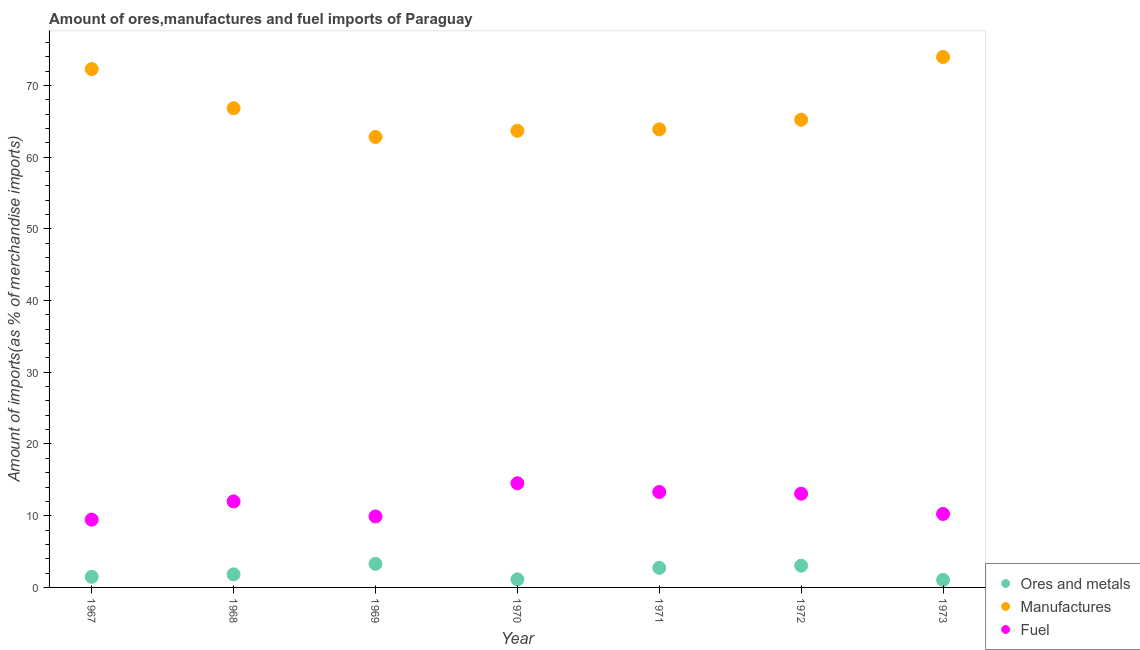How many different coloured dotlines are there?
Provide a succinct answer. 3. Is the number of dotlines equal to the number of legend labels?
Make the answer very short. Yes. What is the percentage of fuel imports in 1972?
Your answer should be very brief. 13.07. Across all years, what is the maximum percentage of ores and metals imports?
Provide a short and direct response. 3.28. Across all years, what is the minimum percentage of manufactures imports?
Your answer should be very brief. 62.81. In which year was the percentage of manufactures imports maximum?
Give a very brief answer. 1973. What is the total percentage of fuel imports in the graph?
Your answer should be compact. 82.49. What is the difference between the percentage of fuel imports in 1967 and that in 1969?
Make the answer very short. -0.44. What is the difference between the percentage of ores and metals imports in 1973 and the percentage of fuel imports in 1971?
Offer a very short reply. -12.26. What is the average percentage of ores and metals imports per year?
Your answer should be very brief. 2.07. In the year 1971, what is the difference between the percentage of ores and metals imports and percentage of fuel imports?
Offer a terse response. -10.58. In how many years, is the percentage of fuel imports greater than 54 %?
Your response must be concise. 0. What is the ratio of the percentage of manufactures imports in 1967 to that in 1972?
Provide a succinct answer. 1.11. Is the percentage of fuel imports in 1969 less than that in 1971?
Your answer should be very brief. Yes. Is the difference between the percentage of manufactures imports in 1968 and 1971 greater than the difference between the percentage of ores and metals imports in 1968 and 1971?
Keep it short and to the point. Yes. What is the difference between the highest and the second highest percentage of manufactures imports?
Provide a short and direct response. 1.69. What is the difference between the highest and the lowest percentage of manufactures imports?
Offer a very short reply. 11.15. Is it the case that in every year, the sum of the percentage of ores and metals imports and percentage of manufactures imports is greater than the percentage of fuel imports?
Give a very brief answer. Yes. How many dotlines are there?
Give a very brief answer. 3. How many years are there in the graph?
Make the answer very short. 7. What is the difference between two consecutive major ticks on the Y-axis?
Offer a terse response. 10. Are the values on the major ticks of Y-axis written in scientific E-notation?
Your answer should be compact. No. Does the graph contain any zero values?
Ensure brevity in your answer.  No. How many legend labels are there?
Make the answer very short. 3. What is the title of the graph?
Your answer should be very brief. Amount of ores,manufactures and fuel imports of Paraguay. Does "Female employers" appear as one of the legend labels in the graph?
Provide a succinct answer. No. What is the label or title of the Y-axis?
Ensure brevity in your answer.  Amount of imports(as % of merchandise imports). What is the Amount of imports(as % of merchandise imports) of Ores and metals in 1967?
Provide a short and direct response. 1.48. What is the Amount of imports(as % of merchandise imports) in Manufactures in 1967?
Offer a terse response. 72.27. What is the Amount of imports(as % of merchandise imports) of Fuel in 1967?
Offer a very short reply. 9.46. What is the Amount of imports(as % of merchandise imports) of Ores and metals in 1968?
Make the answer very short. 1.82. What is the Amount of imports(as % of merchandise imports) of Manufactures in 1968?
Your answer should be compact. 66.82. What is the Amount of imports(as % of merchandise imports) in Fuel in 1968?
Offer a terse response. 11.99. What is the Amount of imports(as % of merchandise imports) in Ores and metals in 1969?
Your answer should be compact. 3.28. What is the Amount of imports(as % of merchandise imports) in Manufactures in 1969?
Offer a terse response. 62.81. What is the Amount of imports(as % of merchandise imports) in Fuel in 1969?
Provide a succinct answer. 9.9. What is the Amount of imports(as % of merchandise imports) in Ores and metals in 1970?
Your answer should be very brief. 1.12. What is the Amount of imports(as % of merchandise imports) in Manufactures in 1970?
Make the answer very short. 63.67. What is the Amount of imports(as % of merchandise imports) of Fuel in 1970?
Make the answer very short. 14.52. What is the Amount of imports(as % of merchandise imports) of Ores and metals in 1971?
Ensure brevity in your answer.  2.73. What is the Amount of imports(as % of merchandise imports) in Manufactures in 1971?
Your answer should be compact. 63.87. What is the Amount of imports(as % of merchandise imports) of Fuel in 1971?
Offer a very short reply. 13.31. What is the Amount of imports(as % of merchandise imports) of Ores and metals in 1972?
Your answer should be very brief. 3.03. What is the Amount of imports(as % of merchandise imports) of Manufactures in 1972?
Make the answer very short. 65.21. What is the Amount of imports(as % of merchandise imports) of Fuel in 1972?
Offer a terse response. 13.07. What is the Amount of imports(as % of merchandise imports) of Ores and metals in 1973?
Make the answer very short. 1.05. What is the Amount of imports(as % of merchandise imports) in Manufactures in 1973?
Give a very brief answer. 73.96. What is the Amount of imports(as % of merchandise imports) in Fuel in 1973?
Make the answer very short. 10.24. Across all years, what is the maximum Amount of imports(as % of merchandise imports) in Ores and metals?
Give a very brief answer. 3.28. Across all years, what is the maximum Amount of imports(as % of merchandise imports) of Manufactures?
Offer a very short reply. 73.96. Across all years, what is the maximum Amount of imports(as % of merchandise imports) in Fuel?
Provide a succinct answer. 14.52. Across all years, what is the minimum Amount of imports(as % of merchandise imports) in Ores and metals?
Provide a short and direct response. 1.05. Across all years, what is the minimum Amount of imports(as % of merchandise imports) in Manufactures?
Your answer should be compact. 62.81. Across all years, what is the minimum Amount of imports(as % of merchandise imports) in Fuel?
Your answer should be very brief. 9.46. What is the total Amount of imports(as % of merchandise imports) of Ores and metals in the graph?
Keep it short and to the point. 14.52. What is the total Amount of imports(as % of merchandise imports) in Manufactures in the graph?
Provide a short and direct response. 468.61. What is the total Amount of imports(as % of merchandise imports) of Fuel in the graph?
Your answer should be very brief. 82.49. What is the difference between the Amount of imports(as % of merchandise imports) in Ores and metals in 1967 and that in 1968?
Offer a very short reply. -0.35. What is the difference between the Amount of imports(as % of merchandise imports) of Manufactures in 1967 and that in 1968?
Keep it short and to the point. 5.45. What is the difference between the Amount of imports(as % of merchandise imports) of Fuel in 1967 and that in 1968?
Offer a very short reply. -2.53. What is the difference between the Amount of imports(as % of merchandise imports) of Ores and metals in 1967 and that in 1969?
Your response must be concise. -1.81. What is the difference between the Amount of imports(as % of merchandise imports) of Manufactures in 1967 and that in 1969?
Your response must be concise. 9.46. What is the difference between the Amount of imports(as % of merchandise imports) in Fuel in 1967 and that in 1969?
Give a very brief answer. -0.44. What is the difference between the Amount of imports(as % of merchandise imports) of Ores and metals in 1967 and that in 1970?
Give a very brief answer. 0.35. What is the difference between the Amount of imports(as % of merchandise imports) of Manufactures in 1967 and that in 1970?
Provide a succinct answer. 8.6. What is the difference between the Amount of imports(as % of merchandise imports) of Fuel in 1967 and that in 1970?
Provide a succinct answer. -5.07. What is the difference between the Amount of imports(as % of merchandise imports) of Ores and metals in 1967 and that in 1971?
Make the answer very short. -1.25. What is the difference between the Amount of imports(as % of merchandise imports) in Manufactures in 1967 and that in 1971?
Make the answer very short. 8.4. What is the difference between the Amount of imports(as % of merchandise imports) in Fuel in 1967 and that in 1971?
Provide a short and direct response. -3.85. What is the difference between the Amount of imports(as % of merchandise imports) of Ores and metals in 1967 and that in 1972?
Your answer should be compact. -1.55. What is the difference between the Amount of imports(as % of merchandise imports) in Manufactures in 1967 and that in 1972?
Your answer should be compact. 7.06. What is the difference between the Amount of imports(as % of merchandise imports) of Fuel in 1967 and that in 1972?
Your response must be concise. -3.61. What is the difference between the Amount of imports(as % of merchandise imports) in Ores and metals in 1967 and that in 1973?
Ensure brevity in your answer.  0.43. What is the difference between the Amount of imports(as % of merchandise imports) of Manufactures in 1967 and that in 1973?
Provide a short and direct response. -1.69. What is the difference between the Amount of imports(as % of merchandise imports) in Fuel in 1967 and that in 1973?
Give a very brief answer. -0.79. What is the difference between the Amount of imports(as % of merchandise imports) in Ores and metals in 1968 and that in 1969?
Provide a succinct answer. -1.46. What is the difference between the Amount of imports(as % of merchandise imports) in Manufactures in 1968 and that in 1969?
Give a very brief answer. 4.01. What is the difference between the Amount of imports(as % of merchandise imports) in Fuel in 1968 and that in 1969?
Offer a very short reply. 2.09. What is the difference between the Amount of imports(as % of merchandise imports) of Ores and metals in 1968 and that in 1970?
Your response must be concise. 0.7. What is the difference between the Amount of imports(as % of merchandise imports) in Manufactures in 1968 and that in 1970?
Ensure brevity in your answer.  3.15. What is the difference between the Amount of imports(as % of merchandise imports) in Fuel in 1968 and that in 1970?
Your response must be concise. -2.53. What is the difference between the Amount of imports(as % of merchandise imports) in Ores and metals in 1968 and that in 1971?
Give a very brief answer. -0.9. What is the difference between the Amount of imports(as % of merchandise imports) in Manufactures in 1968 and that in 1971?
Your answer should be very brief. 2.95. What is the difference between the Amount of imports(as % of merchandise imports) in Fuel in 1968 and that in 1971?
Keep it short and to the point. -1.32. What is the difference between the Amount of imports(as % of merchandise imports) of Ores and metals in 1968 and that in 1972?
Offer a very short reply. -1.2. What is the difference between the Amount of imports(as % of merchandise imports) in Manufactures in 1968 and that in 1972?
Your response must be concise. 1.6. What is the difference between the Amount of imports(as % of merchandise imports) in Fuel in 1968 and that in 1972?
Make the answer very short. -1.08. What is the difference between the Amount of imports(as % of merchandise imports) in Ores and metals in 1968 and that in 1973?
Give a very brief answer. 0.77. What is the difference between the Amount of imports(as % of merchandise imports) in Manufactures in 1968 and that in 1973?
Your answer should be compact. -7.15. What is the difference between the Amount of imports(as % of merchandise imports) of Fuel in 1968 and that in 1973?
Your answer should be very brief. 1.75. What is the difference between the Amount of imports(as % of merchandise imports) in Ores and metals in 1969 and that in 1970?
Ensure brevity in your answer.  2.16. What is the difference between the Amount of imports(as % of merchandise imports) of Manufactures in 1969 and that in 1970?
Make the answer very short. -0.86. What is the difference between the Amount of imports(as % of merchandise imports) of Fuel in 1969 and that in 1970?
Offer a terse response. -4.62. What is the difference between the Amount of imports(as % of merchandise imports) in Ores and metals in 1969 and that in 1971?
Provide a succinct answer. 0.55. What is the difference between the Amount of imports(as % of merchandise imports) of Manufactures in 1969 and that in 1971?
Provide a succinct answer. -1.06. What is the difference between the Amount of imports(as % of merchandise imports) in Fuel in 1969 and that in 1971?
Give a very brief answer. -3.41. What is the difference between the Amount of imports(as % of merchandise imports) in Ores and metals in 1969 and that in 1972?
Provide a short and direct response. 0.25. What is the difference between the Amount of imports(as % of merchandise imports) in Manufactures in 1969 and that in 1972?
Make the answer very short. -2.4. What is the difference between the Amount of imports(as % of merchandise imports) of Fuel in 1969 and that in 1972?
Your response must be concise. -3.17. What is the difference between the Amount of imports(as % of merchandise imports) of Ores and metals in 1969 and that in 1973?
Give a very brief answer. 2.23. What is the difference between the Amount of imports(as % of merchandise imports) in Manufactures in 1969 and that in 1973?
Your answer should be very brief. -11.15. What is the difference between the Amount of imports(as % of merchandise imports) in Fuel in 1969 and that in 1973?
Your response must be concise. -0.34. What is the difference between the Amount of imports(as % of merchandise imports) of Ores and metals in 1970 and that in 1971?
Your answer should be compact. -1.61. What is the difference between the Amount of imports(as % of merchandise imports) in Manufactures in 1970 and that in 1971?
Give a very brief answer. -0.2. What is the difference between the Amount of imports(as % of merchandise imports) of Fuel in 1970 and that in 1971?
Provide a succinct answer. 1.22. What is the difference between the Amount of imports(as % of merchandise imports) in Ores and metals in 1970 and that in 1972?
Offer a very short reply. -1.91. What is the difference between the Amount of imports(as % of merchandise imports) of Manufactures in 1970 and that in 1972?
Make the answer very short. -1.55. What is the difference between the Amount of imports(as % of merchandise imports) in Fuel in 1970 and that in 1972?
Offer a very short reply. 1.46. What is the difference between the Amount of imports(as % of merchandise imports) of Ores and metals in 1970 and that in 1973?
Your response must be concise. 0.07. What is the difference between the Amount of imports(as % of merchandise imports) in Manufactures in 1970 and that in 1973?
Your response must be concise. -10.3. What is the difference between the Amount of imports(as % of merchandise imports) in Fuel in 1970 and that in 1973?
Provide a short and direct response. 4.28. What is the difference between the Amount of imports(as % of merchandise imports) in Ores and metals in 1971 and that in 1972?
Your response must be concise. -0.3. What is the difference between the Amount of imports(as % of merchandise imports) in Manufactures in 1971 and that in 1972?
Your answer should be compact. -1.35. What is the difference between the Amount of imports(as % of merchandise imports) of Fuel in 1971 and that in 1972?
Offer a very short reply. 0.24. What is the difference between the Amount of imports(as % of merchandise imports) in Ores and metals in 1971 and that in 1973?
Give a very brief answer. 1.68. What is the difference between the Amount of imports(as % of merchandise imports) in Manufactures in 1971 and that in 1973?
Keep it short and to the point. -10.1. What is the difference between the Amount of imports(as % of merchandise imports) in Fuel in 1971 and that in 1973?
Offer a terse response. 3.07. What is the difference between the Amount of imports(as % of merchandise imports) of Ores and metals in 1972 and that in 1973?
Your answer should be compact. 1.98. What is the difference between the Amount of imports(as % of merchandise imports) in Manufactures in 1972 and that in 1973?
Ensure brevity in your answer.  -8.75. What is the difference between the Amount of imports(as % of merchandise imports) of Fuel in 1972 and that in 1973?
Your answer should be very brief. 2.83. What is the difference between the Amount of imports(as % of merchandise imports) of Ores and metals in 1967 and the Amount of imports(as % of merchandise imports) of Manufactures in 1968?
Provide a short and direct response. -65.34. What is the difference between the Amount of imports(as % of merchandise imports) in Ores and metals in 1967 and the Amount of imports(as % of merchandise imports) in Fuel in 1968?
Keep it short and to the point. -10.51. What is the difference between the Amount of imports(as % of merchandise imports) in Manufactures in 1967 and the Amount of imports(as % of merchandise imports) in Fuel in 1968?
Give a very brief answer. 60.28. What is the difference between the Amount of imports(as % of merchandise imports) of Ores and metals in 1967 and the Amount of imports(as % of merchandise imports) of Manufactures in 1969?
Make the answer very short. -61.33. What is the difference between the Amount of imports(as % of merchandise imports) of Ores and metals in 1967 and the Amount of imports(as % of merchandise imports) of Fuel in 1969?
Offer a very short reply. -8.42. What is the difference between the Amount of imports(as % of merchandise imports) of Manufactures in 1967 and the Amount of imports(as % of merchandise imports) of Fuel in 1969?
Provide a succinct answer. 62.37. What is the difference between the Amount of imports(as % of merchandise imports) in Ores and metals in 1967 and the Amount of imports(as % of merchandise imports) in Manufactures in 1970?
Offer a terse response. -62.19. What is the difference between the Amount of imports(as % of merchandise imports) of Ores and metals in 1967 and the Amount of imports(as % of merchandise imports) of Fuel in 1970?
Offer a terse response. -13.05. What is the difference between the Amount of imports(as % of merchandise imports) of Manufactures in 1967 and the Amount of imports(as % of merchandise imports) of Fuel in 1970?
Your response must be concise. 57.75. What is the difference between the Amount of imports(as % of merchandise imports) of Ores and metals in 1967 and the Amount of imports(as % of merchandise imports) of Manufactures in 1971?
Offer a very short reply. -62.39. What is the difference between the Amount of imports(as % of merchandise imports) of Ores and metals in 1967 and the Amount of imports(as % of merchandise imports) of Fuel in 1971?
Keep it short and to the point. -11.83. What is the difference between the Amount of imports(as % of merchandise imports) of Manufactures in 1967 and the Amount of imports(as % of merchandise imports) of Fuel in 1971?
Provide a short and direct response. 58.96. What is the difference between the Amount of imports(as % of merchandise imports) in Ores and metals in 1967 and the Amount of imports(as % of merchandise imports) in Manufactures in 1972?
Give a very brief answer. -63.74. What is the difference between the Amount of imports(as % of merchandise imports) in Ores and metals in 1967 and the Amount of imports(as % of merchandise imports) in Fuel in 1972?
Provide a short and direct response. -11.59. What is the difference between the Amount of imports(as % of merchandise imports) in Manufactures in 1967 and the Amount of imports(as % of merchandise imports) in Fuel in 1972?
Offer a terse response. 59.2. What is the difference between the Amount of imports(as % of merchandise imports) in Ores and metals in 1967 and the Amount of imports(as % of merchandise imports) in Manufactures in 1973?
Provide a short and direct response. -72.48. What is the difference between the Amount of imports(as % of merchandise imports) of Ores and metals in 1967 and the Amount of imports(as % of merchandise imports) of Fuel in 1973?
Keep it short and to the point. -8.76. What is the difference between the Amount of imports(as % of merchandise imports) of Manufactures in 1967 and the Amount of imports(as % of merchandise imports) of Fuel in 1973?
Make the answer very short. 62.03. What is the difference between the Amount of imports(as % of merchandise imports) of Ores and metals in 1968 and the Amount of imports(as % of merchandise imports) of Manufactures in 1969?
Give a very brief answer. -60.98. What is the difference between the Amount of imports(as % of merchandise imports) of Ores and metals in 1968 and the Amount of imports(as % of merchandise imports) of Fuel in 1969?
Your answer should be compact. -8.07. What is the difference between the Amount of imports(as % of merchandise imports) in Manufactures in 1968 and the Amount of imports(as % of merchandise imports) in Fuel in 1969?
Provide a succinct answer. 56.92. What is the difference between the Amount of imports(as % of merchandise imports) of Ores and metals in 1968 and the Amount of imports(as % of merchandise imports) of Manufactures in 1970?
Keep it short and to the point. -61.84. What is the difference between the Amount of imports(as % of merchandise imports) in Ores and metals in 1968 and the Amount of imports(as % of merchandise imports) in Fuel in 1970?
Your response must be concise. -12.7. What is the difference between the Amount of imports(as % of merchandise imports) in Manufactures in 1968 and the Amount of imports(as % of merchandise imports) in Fuel in 1970?
Provide a succinct answer. 52.29. What is the difference between the Amount of imports(as % of merchandise imports) in Ores and metals in 1968 and the Amount of imports(as % of merchandise imports) in Manufactures in 1971?
Provide a short and direct response. -62.04. What is the difference between the Amount of imports(as % of merchandise imports) of Ores and metals in 1968 and the Amount of imports(as % of merchandise imports) of Fuel in 1971?
Provide a short and direct response. -11.48. What is the difference between the Amount of imports(as % of merchandise imports) of Manufactures in 1968 and the Amount of imports(as % of merchandise imports) of Fuel in 1971?
Provide a succinct answer. 53.51. What is the difference between the Amount of imports(as % of merchandise imports) of Ores and metals in 1968 and the Amount of imports(as % of merchandise imports) of Manufactures in 1972?
Provide a short and direct response. -63.39. What is the difference between the Amount of imports(as % of merchandise imports) in Ores and metals in 1968 and the Amount of imports(as % of merchandise imports) in Fuel in 1972?
Offer a terse response. -11.24. What is the difference between the Amount of imports(as % of merchandise imports) of Manufactures in 1968 and the Amount of imports(as % of merchandise imports) of Fuel in 1972?
Keep it short and to the point. 53.75. What is the difference between the Amount of imports(as % of merchandise imports) in Ores and metals in 1968 and the Amount of imports(as % of merchandise imports) in Manufactures in 1973?
Make the answer very short. -72.14. What is the difference between the Amount of imports(as % of merchandise imports) of Ores and metals in 1968 and the Amount of imports(as % of merchandise imports) of Fuel in 1973?
Provide a succinct answer. -8.42. What is the difference between the Amount of imports(as % of merchandise imports) in Manufactures in 1968 and the Amount of imports(as % of merchandise imports) in Fuel in 1973?
Make the answer very short. 56.57. What is the difference between the Amount of imports(as % of merchandise imports) in Ores and metals in 1969 and the Amount of imports(as % of merchandise imports) in Manufactures in 1970?
Your response must be concise. -60.38. What is the difference between the Amount of imports(as % of merchandise imports) in Ores and metals in 1969 and the Amount of imports(as % of merchandise imports) in Fuel in 1970?
Give a very brief answer. -11.24. What is the difference between the Amount of imports(as % of merchandise imports) in Manufactures in 1969 and the Amount of imports(as % of merchandise imports) in Fuel in 1970?
Make the answer very short. 48.29. What is the difference between the Amount of imports(as % of merchandise imports) in Ores and metals in 1969 and the Amount of imports(as % of merchandise imports) in Manufactures in 1971?
Offer a terse response. -60.58. What is the difference between the Amount of imports(as % of merchandise imports) in Ores and metals in 1969 and the Amount of imports(as % of merchandise imports) in Fuel in 1971?
Offer a very short reply. -10.02. What is the difference between the Amount of imports(as % of merchandise imports) in Manufactures in 1969 and the Amount of imports(as % of merchandise imports) in Fuel in 1971?
Give a very brief answer. 49.5. What is the difference between the Amount of imports(as % of merchandise imports) of Ores and metals in 1969 and the Amount of imports(as % of merchandise imports) of Manufactures in 1972?
Your response must be concise. -61.93. What is the difference between the Amount of imports(as % of merchandise imports) in Ores and metals in 1969 and the Amount of imports(as % of merchandise imports) in Fuel in 1972?
Keep it short and to the point. -9.78. What is the difference between the Amount of imports(as % of merchandise imports) of Manufactures in 1969 and the Amount of imports(as % of merchandise imports) of Fuel in 1972?
Your answer should be compact. 49.74. What is the difference between the Amount of imports(as % of merchandise imports) of Ores and metals in 1969 and the Amount of imports(as % of merchandise imports) of Manufactures in 1973?
Keep it short and to the point. -70.68. What is the difference between the Amount of imports(as % of merchandise imports) of Ores and metals in 1969 and the Amount of imports(as % of merchandise imports) of Fuel in 1973?
Your answer should be very brief. -6.96. What is the difference between the Amount of imports(as % of merchandise imports) of Manufactures in 1969 and the Amount of imports(as % of merchandise imports) of Fuel in 1973?
Offer a terse response. 52.57. What is the difference between the Amount of imports(as % of merchandise imports) in Ores and metals in 1970 and the Amount of imports(as % of merchandise imports) in Manufactures in 1971?
Offer a terse response. -62.74. What is the difference between the Amount of imports(as % of merchandise imports) in Ores and metals in 1970 and the Amount of imports(as % of merchandise imports) in Fuel in 1971?
Provide a succinct answer. -12.18. What is the difference between the Amount of imports(as % of merchandise imports) in Manufactures in 1970 and the Amount of imports(as % of merchandise imports) in Fuel in 1971?
Provide a short and direct response. 50.36. What is the difference between the Amount of imports(as % of merchandise imports) of Ores and metals in 1970 and the Amount of imports(as % of merchandise imports) of Manufactures in 1972?
Keep it short and to the point. -64.09. What is the difference between the Amount of imports(as % of merchandise imports) in Ores and metals in 1970 and the Amount of imports(as % of merchandise imports) in Fuel in 1972?
Offer a very short reply. -11.94. What is the difference between the Amount of imports(as % of merchandise imports) in Manufactures in 1970 and the Amount of imports(as % of merchandise imports) in Fuel in 1972?
Keep it short and to the point. 50.6. What is the difference between the Amount of imports(as % of merchandise imports) in Ores and metals in 1970 and the Amount of imports(as % of merchandise imports) in Manufactures in 1973?
Offer a very short reply. -72.84. What is the difference between the Amount of imports(as % of merchandise imports) in Ores and metals in 1970 and the Amount of imports(as % of merchandise imports) in Fuel in 1973?
Keep it short and to the point. -9.12. What is the difference between the Amount of imports(as % of merchandise imports) of Manufactures in 1970 and the Amount of imports(as % of merchandise imports) of Fuel in 1973?
Ensure brevity in your answer.  53.43. What is the difference between the Amount of imports(as % of merchandise imports) in Ores and metals in 1971 and the Amount of imports(as % of merchandise imports) in Manufactures in 1972?
Give a very brief answer. -62.48. What is the difference between the Amount of imports(as % of merchandise imports) of Ores and metals in 1971 and the Amount of imports(as % of merchandise imports) of Fuel in 1972?
Provide a succinct answer. -10.34. What is the difference between the Amount of imports(as % of merchandise imports) of Manufactures in 1971 and the Amount of imports(as % of merchandise imports) of Fuel in 1972?
Your response must be concise. 50.8. What is the difference between the Amount of imports(as % of merchandise imports) of Ores and metals in 1971 and the Amount of imports(as % of merchandise imports) of Manufactures in 1973?
Offer a very short reply. -71.23. What is the difference between the Amount of imports(as % of merchandise imports) of Ores and metals in 1971 and the Amount of imports(as % of merchandise imports) of Fuel in 1973?
Provide a short and direct response. -7.51. What is the difference between the Amount of imports(as % of merchandise imports) in Manufactures in 1971 and the Amount of imports(as % of merchandise imports) in Fuel in 1973?
Provide a succinct answer. 53.63. What is the difference between the Amount of imports(as % of merchandise imports) in Ores and metals in 1972 and the Amount of imports(as % of merchandise imports) in Manufactures in 1973?
Your response must be concise. -70.93. What is the difference between the Amount of imports(as % of merchandise imports) in Ores and metals in 1972 and the Amount of imports(as % of merchandise imports) in Fuel in 1973?
Provide a succinct answer. -7.21. What is the difference between the Amount of imports(as % of merchandise imports) of Manufactures in 1972 and the Amount of imports(as % of merchandise imports) of Fuel in 1973?
Provide a succinct answer. 54.97. What is the average Amount of imports(as % of merchandise imports) of Ores and metals per year?
Make the answer very short. 2.07. What is the average Amount of imports(as % of merchandise imports) in Manufactures per year?
Provide a short and direct response. 66.94. What is the average Amount of imports(as % of merchandise imports) of Fuel per year?
Provide a succinct answer. 11.78. In the year 1967, what is the difference between the Amount of imports(as % of merchandise imports) in Ores and metals and Amount of imports(as % of merchandise imports) in Manufactures?
Ensure brevity in your answer.  -70.79. In the year 1967, what is the difference between the Amount of imports(as % of merchandise imports) in Ores and metals and Amount of imports(as % of merchandise imports) in Fuel?
Your answer should be compact. -7.98. In the year 1967, what is the difference between the Amount of imports(as % of merchandise imports) in Manufactures and Amount of imports(as % of merchandise imports) in Fuel?
Your response must be concise. 62.82. In the year 1968, what is the difference between the Amount of imports(as % of merchandise imports) of Ores and metals and Amount of imports(as % of merchandise imports) of Manufactures?
Provide a short and direct response. -64.99. In the year 1968, what is the difference between the Amount of imports(as % of merchandise imports) in Ores and metals and Amount of imports(as % of merchandise imports) in Fuel?
Provide a succinct answer. -10.16. In the year 1968, what is the difference between the Amount of imports(as % of merchandise imports) in Manufactures and Amount of imports(as % of merchandise imports) in Fuel?
Offer a very short reply. 54.83. In the year 1969, what is the difference between the Amount of imports(as % of merchandise imports) in Ores and metals and Amount of imports(as % of merchandise imports) in Manufactures?
Offer a very short reply. -59.53. In the year 1969, what is the difference between the Amount of imports(as % of merchandise imports) of Ores and metals and Amount of imports(as % of merchandise imports) of Fuel?
Your response must be concise. -6.62. In the year 1969, what is the difference between the Amount of imports(as % of merchandise imports) of Manufactures and Amount of imports(as % of merchandise imports) of Fuel?
Your answer should be compact. 52.91. In the year 1970, what is the difference between the Amount of imports(as % of merchandise imports) of Ores and metals and Amount of imports(as % of merchandise imports) of Manufactures?
Your answer should be very brief. -62.54. In the year 1970, what is the difference between the Amount of imports(as % of merchandise imports) in Ores and metals and Amount of imports(as % of merchandise imports) in Fuel?
Ensure brevity in your answer.  -13.4. In the year 1970, what is the difference between the Amount of imports(as % of merchandise imports) of Manufactures and Amount of imports(as % of merchandise imports) of Fuel?
Provide a succinct answer. 49.14. In the year 1971, what is the difference between the Amount of imports(as % of merchandise imports) in Ores and metals and Amount of imports(as % of merchandise imports) in Manufactures?
Your response must be concise. -61.14. In the year 1971, what is the difference between the Amount of imports(as % of merchandise imports) in Ores and metals and Amount of imports(as % of merchandise imports) in Fuel?
Provide a short and direct response. -10.58. In the year 1971, what is the difference between the Amount of imports(as % of merchandise imports) in Manufactures and Amount of imports(as % of merchandise imports) in Fuel?
Give a very brief answer. 50.56. In the year 1972, what is the difference between the Amount of imports(as % of merchandise imports) in Ores and metals and Amount of imports(as % of merchandise imports) in Manufactures?
Your response must be concise. -62.18. In the year 1972, what is the difference between the Amount of imports(as % of merchandise imports) in Ores and metals and Amount of imports(as % of merchandise imports) in Fuel?
Give a very brief answer. -10.04. In the year 1972, what is the difference between the Amount of imports(as % of merchandise imports) in Manufactures and Amount of imports(as % of merchandise imports) in Fuel?
Make the answer very short. 52.15. In the year 1973, what is the difference between the Amount of imports(as % of merchandise imports) of Ores and metals and Amount of imports(as % of merchandise imports) of Manufactures?
Offer a very short reply. -72.91. In the year 1973, what is the difference between the Amount of imports(as % of merchandise imports) of Ores and metals and Amount of imports(as % of merchandise imports) of Fuel?
Your response must be concise. -9.19. In the year 1973, what is the difference between the Amount of imports(as % of merchandise imports) in Manufactures and Amount of imports(as % of merchandise imports) in Fuel?
Offer a very short reply. 63.72. What is the ratio of the Amount of imports(as % of merchandise imports) of Ores and metals in 1967 to that in 1968?
Your response must be concise. 0.81. What is the ratio of the Amount of imports(as % of merchandise imports) of Manufactures in 1967 to that in 1968?
Your answer should be very brief. 1.08. What is the ratio of the Amount of imports(as % of merchandise imports) of Fuel in 1967 to that in 1968?
Your response must be concise. 0.79. What is the ratio of the Amount of imports(as % of merchandise imports) in Ores and metals in 1967 to that in 1969?
Your answer should be compact. 0.45. What is the ratio of the Amount of imports(as % of merchandise imports) in Manufactures in 1967 to that in 1969?
Your answer should be very brief. 1.15. What is the ratio of the Amount of imports(as % of merchandise imports) in Fuel in 1967 to that in 1969?
Ensure brevity in your answer.  0.96. What is the ratio of the Amount of imports(as % of merchandise imports) of Ores and metals in 1967 to that in 1970?
Ensure brevity in your answer.  1.32. What is the ratio of the Amount of imports(as % of merchandise imports) of Manufactures in 1967 to that in 1970?
Your answer should be compact. 1.14. What is the ratio of the Amount of imports(as % of merchandise imports) in Fuel in 1967 to that in 1970?
Make the answer very short. 0.65. What is the ratio of the Amount of imports(as % of merchandise imports) in Ores and metals in 1967 to that in 1971?
Offer a terse response. 0.54. What is the ratio of the Amount of imports(as % of merchandise imports) in Manufactures in 1967 to that in 1971?
Your answer should be very brief. 1.13. What is the ratio of the Amount of imports(as % of merchandise imports) in Fuel in 1967 to that in 1971?
Offer a very short reply. 0.71. What is the ratio of the Amount of imports(as % of merchandise imports) of Ores and metals in 1967 to that in 1972?
Provide a succinct answer. 0.49. What is the ratio of the Amount of imports(as % of merchandise imports) in Manufactures in 1967 to that in 1972?
Offer a terse response. 1.11. What is the ratio of the Amount of imports(as % of merchandise imports) of Fuel in 1967 to that in 1972?
Provide a succinct answer. 0.72. What is the ratio of the Amount of imports(as % of merchandise imports) in Ores and metals in 1967 to that in 1973?
Your response must be concise. 1.41. What is the ratio of the Amount of imports(as % of merchandise imports) of Manufactures in 1967 to that in 1973?
Give a very brief answer. 0.98. What is the ratio of the Amount of imports(as % of merchandise imports) of Fuel in 1967 to that in 1973?
Provide a short and direct response. 0.92. What is the ratio of the Amount of imports(as % of merchandise imports) of Ores and metals in 1968 to that in 1969?
Provide a short and direct response. 0.56. What is the ratio of the Amount of imports(as % of merchandise imports) in Manufactures in 1968 to that in 1969?
Your answer should be compact. 1.06. What is the ratio of the Amount of imports(as % of merchandise imports) in Fuel in 1968 to that in 1969?
Offer a terse response. 1.21. What is the ratio of the Amount of imports(as % of merchandise imports) in Ores and metals in 1968 to that in 1970?
Provide a succinct answer. 1.62. What is the ratio of the Amount of imports(as % of merchandise imports) of Manufactures in 1968 to that in 1970?
Ensure brevity in your answer.  1.05. What is the ratio of the Amount of imports(as % of merchandise imports) of Fuel in 1968 to that in 1970?
Your response must be concise. 0.83. What is the ratio of the Amount of imports(as % of merchandise imports) of Ores and metals in 1968 to that in 1971?
Keep it short and to the point. 0.67. What is the ratio of the Amount of imports(as % of merchandise imports) in Manufactures in 1968 to that in 1971?
Offer a terse response. 1.05. What is the ratio of the Amount of imports(as % of merchandise imports) of Fuel in 1968 to that in 1971?
Provide a succinct answer. 0.9. What is the ratio of the Amount of imports(as % of merchandise imports) of Ores and metals in 1968 to that in 1972?
Your answer should be very brief. 0.6. What is the ratio of the Amount of imports(as % of merchandise imports) of Manufactures in 1968 to that in 1972?
Give a very brief answer. 1.02. What is the ratio of the Amount of imports(as % of merchandise imports) of Fuel in 1968 to that in 1972?
Offer a very short reply. 0.92. What is the ratio of the Amount of imports(as % of merchandise imports) of Ores and metals in 1968 to that in 1973?
Your answer should be compact. 1.74. What is the ratio of the Amount of imports(as % of merchandise imports) in Manufactures in 1968 to that in 1973?
Keep it short and to the point. 0.9. What is the ratio of the Amount of imports(as % of merchandise imports) in Fuel in 1968 to that in 1973?
Your answer should be compact. 1.17. What is the ratio of the Amount of imports(as % of merchandise imports) of Ores and metals in 1969 to that in 1970?
Your response must be concise. 2.92. What is the ratio of the Amount of imports(as % of merchandise imports) of Manufactures in 1969 to that in 1970?
Provide a short and direct response. 0.99. What is the ratio of the Amount of imports(as % of merchandise imports) of Fuel in 1969 to that in 1970?
Your answer should be compact. 0.68. What is the ratio of the Amount of imports(as % of merchandise imports) in Ores and metals in 1969 to that in 1971?
Give a very brief answer. 1.2. What is the ratio of the Amount of imports(as % of merchandise imports) in Manufactures in 1969 to that in 1971?
Your response must be concise. 0.98. What is the ratio of the Amount of imports(as % of merchandise imports) in Fuel in 1969 to that in 1971?
Give a very brief answer. 0.74. What is the ratio of the Amount of imports(as % of merchandise imports) of Ores and metals in 1969 to that in 1972?
Make the answer very short. 1.08. What is the ratio of the Amount of imports(as % of merchandise imports) of Manufactures in 1969 to that in 1972?
Provide a short and direct response. 0.96. What is the ratio of the Amount of imports(as % of merchandise imports) in Fuel in 1969 to that in 1972?
Your answer should be compact. 0.76. What is the ratio of the Amount of imports(as % of merchandise imports) of Ores and metals in 1969 to that in 1973?
Your response must be concise. 3.12. What is the ratio of the Amount of imports(as % of merchandise imports) of Manufactures in 1969 to that in 1973?
Offer a terse response. 0.85. What is the ratio of the Amount of imports(as % of merchandise imports) of Fuel in 1969 to that in 1973?
Your response must be concise. 0.97. What is the ratio of the Amount of imports(as % of merchandise imports) of Ores and metals in 1970 to that in 1971?
Your answer should be very brief. 0.41. What is the ratio of the Amount of imports(as % of merchandise imports) of Manufactures in 1970 to that in 1971?
Give a very brief answer. 1. What is the ratio of the Amount of imports(as % of merchandise imports) of Fuel in 1970 to that in 1971?
Make the answer very short. 1.09. What is the ratio of the Amount of imports(as % of merchandise imports) of Ores and metals in 1970 to that in 1972?
Your response must be concise. 0.37. What is the ratio of the Amount of imports(as % of merchandise imports) of Manufactures in 1970 to that in 1972?
Your answer should be very brief. 0.98. What is the ratio of the Amount of imports(as % of merchandise imports) of Fuel in 1970 to that in 1972?
Your response must be concise. 1.11. What is the ratio of the Amount of imports(as % of merchandise imports) of Ores and metals in 1970 to that in 1973?
Offer a terse response. 1.07. What is the ratio of the Amount of imports(as % of merchandise imports) in Manufactures in 1970 to that in 1973?
Keep it short and to the point. 0.86. What is the ratio of the Amount of imports(as % of merchandise imports) in Fuel in 1970 to that in 1973?
Offer a very short reply. 1.42. What is the ratio of the Amount of imports(as % of merchandise imports) of Ores and metals in 1971 to that in 1972?
Your response must be concise. 0.9. What is the ratio of the Amount of imports(as % of merchandise imports) of Manufactures in 1971 to that in 1972?
Offer a very short reply. 0.98. What is the ratio of the Amount of imports(as % of merchandise imports) in Fuel in 1971 to that in 1972?
Keep it short and to the point. 1.02. What is the ratio of the Amount of imports(as % of merchandise imports) in Ores and metals in 1971 to that in 1973?
Provide a succinct answer. 2.6. What is the ratio of the Amount of imports(as % of merchandise imports) in Manufactures in 1971 to that in 1973?
Give a very brief answer. 0.86. What is the ratio of the Amount of imports(as % of merchandise imports) of Fuel in 1971 to that in 1973?
Your answer should be compact. 1.3. What is the ratio of the Amount of imports(as % of merchandise imports) in Ores and metals in 1972 to that in 1973?
Your response must be concise. 2.88. What is the ratio of the Amount of imports(as % of merchandise imports) in Manufactures in 1972 to that in 1973?
Provide a succinct answer. 0.88. What is the ratio of the Amount of imports(as % of merchandise imports) of Fuel in 1972 to that in 1973?
Provide a short and direct response. 1.28. What is the difference between the highest and the second highest Amount of imports(as % of merchandise imports) of Ores and metals?
Make the answer very short. 0.25. What is the difference between the highest and the second highest Amount of imports(as % of merchandise imports) of Manufactures?
Provide a short and direct response. 1.69. What is the difference between the highest and the second highest Amount of imports(as % of merchandise imports) of Fuel?
Offer a very short reply. 1.22. What is the difference between the highest and the lowest Amount of imports(as % of merchandise imports) of Ores and metals?
Offer a terse response. 2.23. What is the difference between the highest and the lowest Amount of imports(as % of merchandise imports) in Manufactures?
Offer a terse response. 11.15. What is the difference between the highest and the lowest Amount of imports(as % of merchandise imports) of Fuel?
Offer a very short reply. 5.07. 